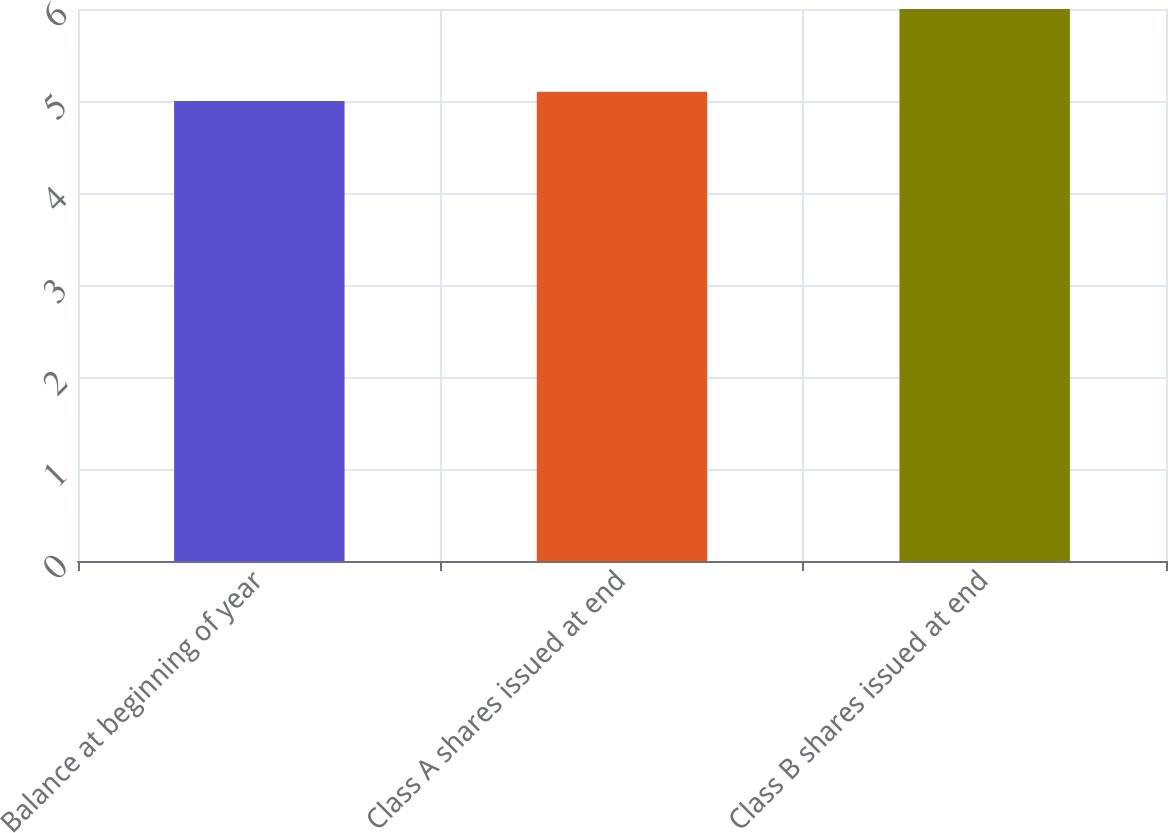<chart> <loc_0><loc_0><loc_500><loc_500><bar_chart><fcel>Balance at beginning of year<fcel>Class A shares issued at end<fcel>Class B shares issued at end<nl><fcel>5<fcel>5.1<fcel>6<nl></chart> 